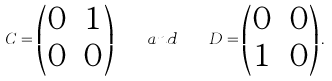Convert formula to latex. <formula><loc_0><loc_0><loc_500><loc_500>C = \begin{pmatrix} 0 & 1 \\ 0 & 0 \end{pmatrix} \quad a n d \quad D = \begin{pmatrix} 0 & 0 \\ 1 & 0 \end{pmatrix} .</formula> 